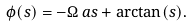Convert formula to latex. <formula><loc_0><loc_0><loc_500><loc_500>\phi ( s ) = - \Omega \, a s + \arctan ( s ) .</formula> 